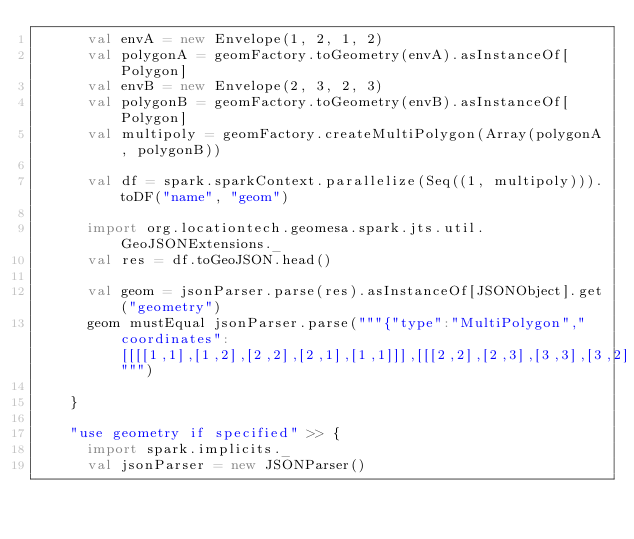<code> <loc_0><loc_0><loc_500><loc_500><_Scala_>      val envA = new Envelope(1, 2, 1, 2)
      val polygonA = geomFactory.toGeometry(envA).asInstanceOf[Polygon]
      val envB = new Envelope(2, 3, 2, 3)
      val polygonB = geomFactory.toGeometry(envB).asInstanceOf[Polygon]
      val multipoly = geomFactory.createMultiPolygon(Array(polygonA, polygonB))

      val df = spark.sparkContext.parallelize(Seq((1, multipoly))).toDF("name", "geom")

      import org.locationtech.geomesa.spark.jts.util.GeoJSONExtensions._
      val res = df.toGeoJSON.head()

      val geom = jsonParser.parse(res).asInstanceOf[JSONObject].get("geometry")
      geom mustEqual jsonParser.parse("""{"type":"MultiPolygon","coordinates":[[[[1,1],[1,2],[2,2],[2,1],[1,1]]],[[[2,2],[2,3],[3,3],[3,2],[2,2]]]]}""")

    }

    "use geometry if specified" >> {
      import spark.implicits._
      val jsonParser = new JSONParser()
</code> 